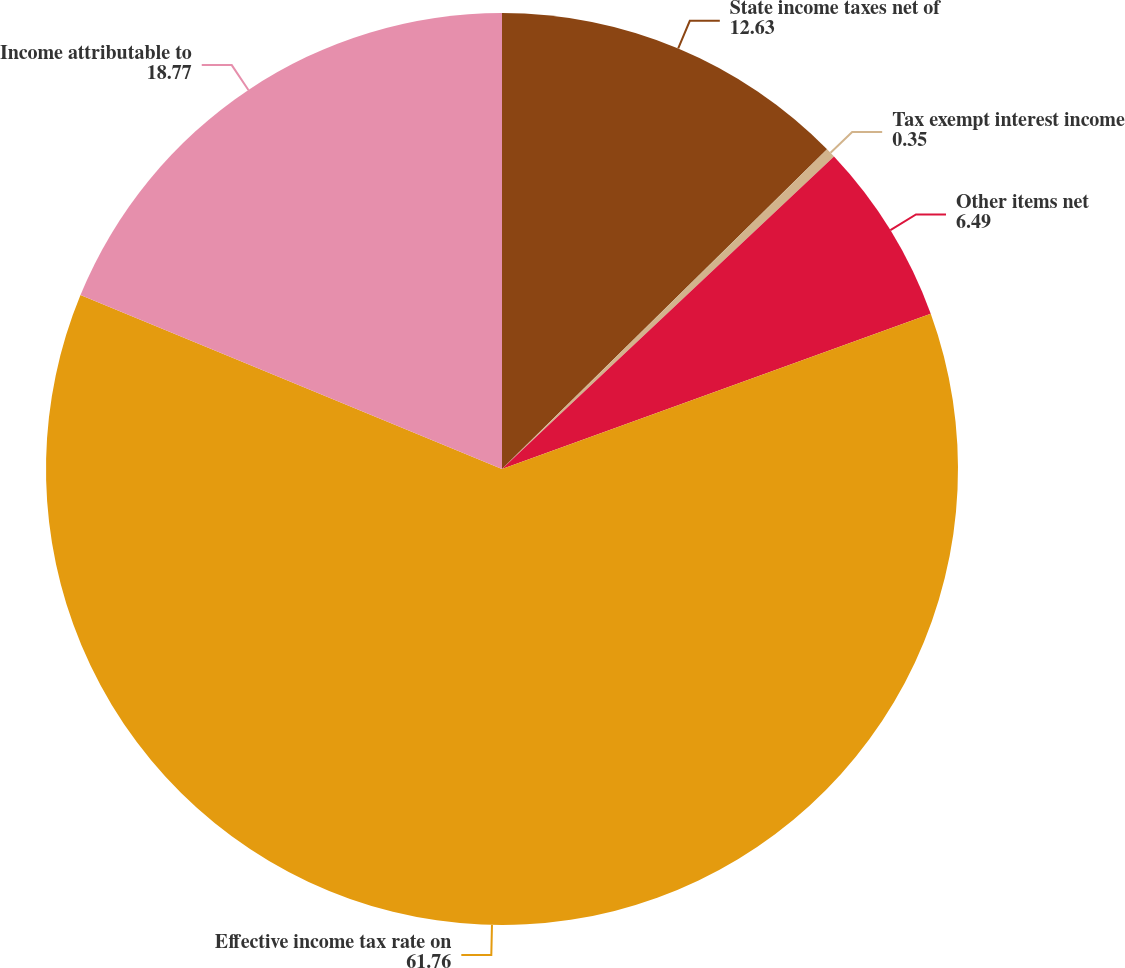<chart> <loc_0><loc_0><loc_500><loc_500><pie_chart><fcel>State income taxes net of<fcel>Tax exempt interest income<fcel>Other items net<fcel>Effective income tax rate on<fcel>Income attributable to<nl><fcel>12.63%<fcel>0.35%<fcel>6.49%<fcel>61.76%<fcel>18.77%<nl></chart> 